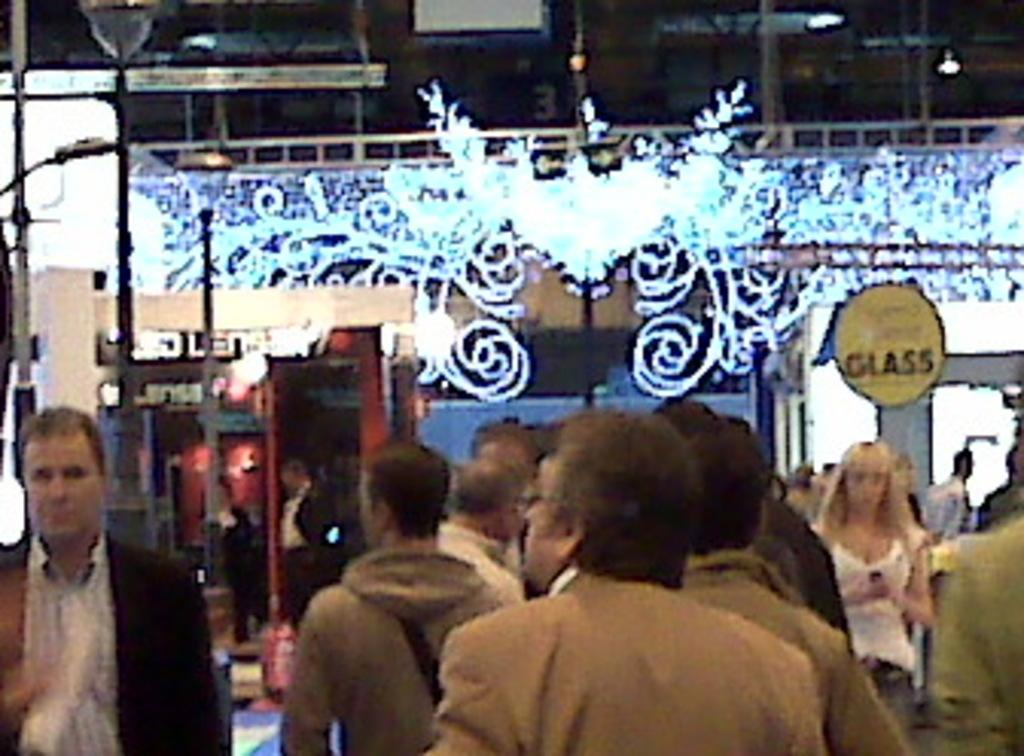What is the main subject of the image? The main subject of the image is a group of people. What objects can be seen in the image besides the people? There are poles, lights, and a board in the image. Can you describe the board in the image? The board is a flat surface with writing or images on it. What is the condition of the background in the image? The background of the image is blurred. What type of plate is being used by the people in the image? There is no plate visible in the image; the people are not eating or using any plates. 